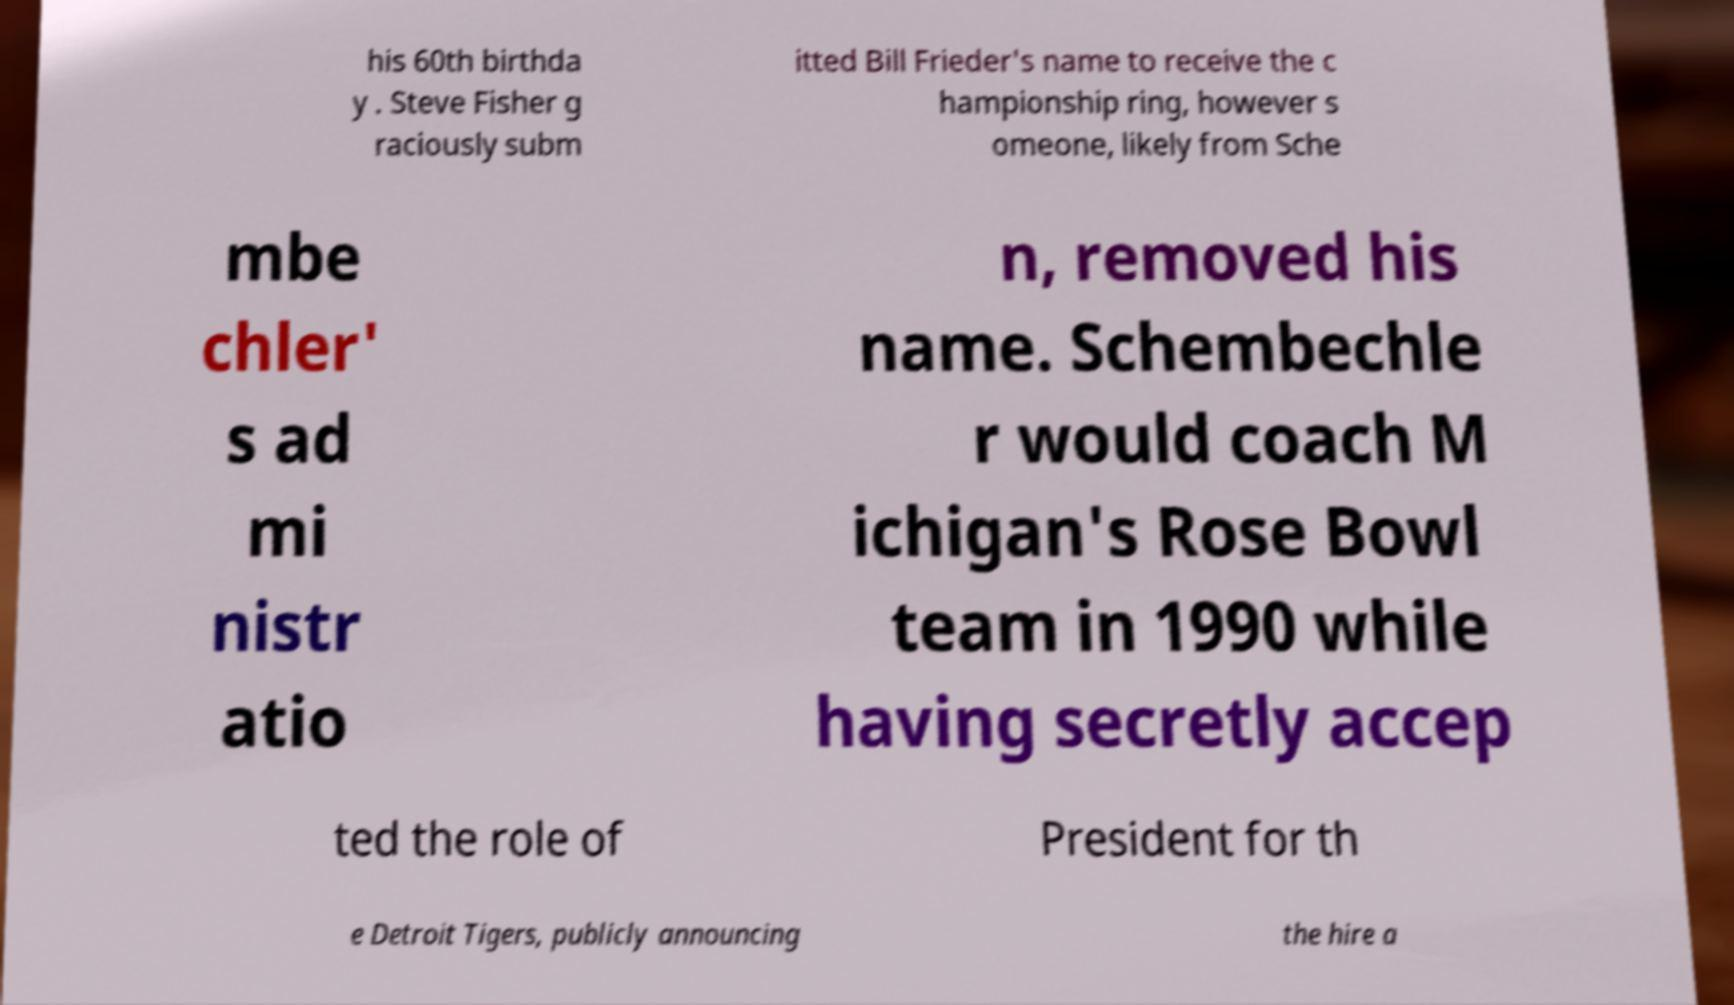Could you extract and type out the text from this image? his 60th birthda y . Steve Fisher g raciously subm itted Bill Frieder's name to receive the c hampionship ring, however s omeone, likely from Sche mbe chler' s ad mi nistr atio n, removed his name. Schembechle r would coach M ichigan's Rose Bowl team in 1990 while having secretly accep ted the role of President for th e Detroit Tigers, publicly announcing the hire a 